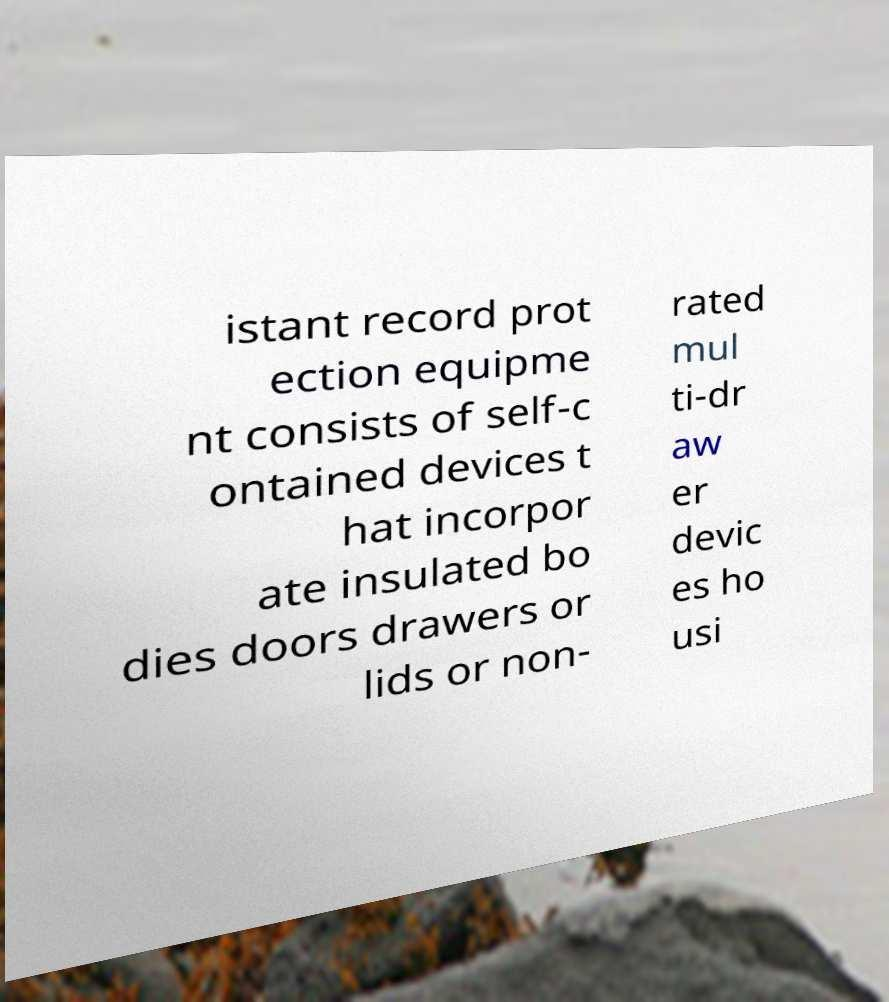Could you assist in decoding the text presented in this image and type it out clearly? istant record prot ection equipme nt consists of self-c ontained devices t hat incorpor ate insulated bo dies doors drawers or lids or non- rated mul ti-dr aw er devic es ho usi 